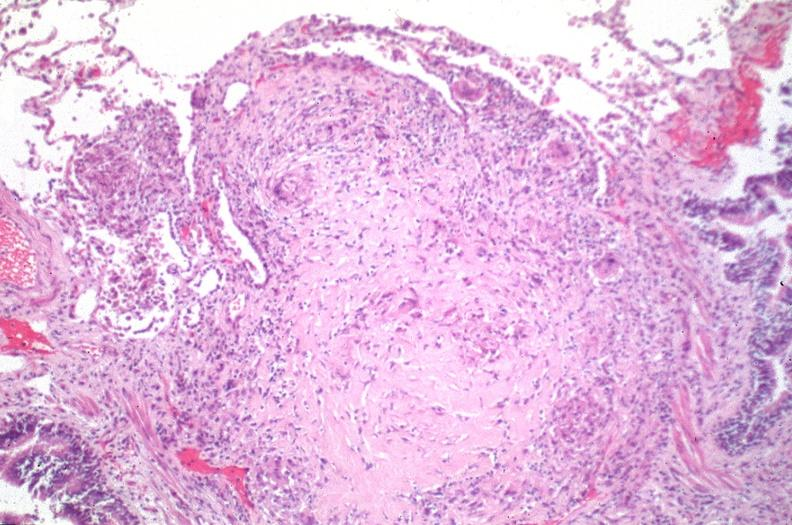where is this?
Answer the question using a single word or phrase. Lung 